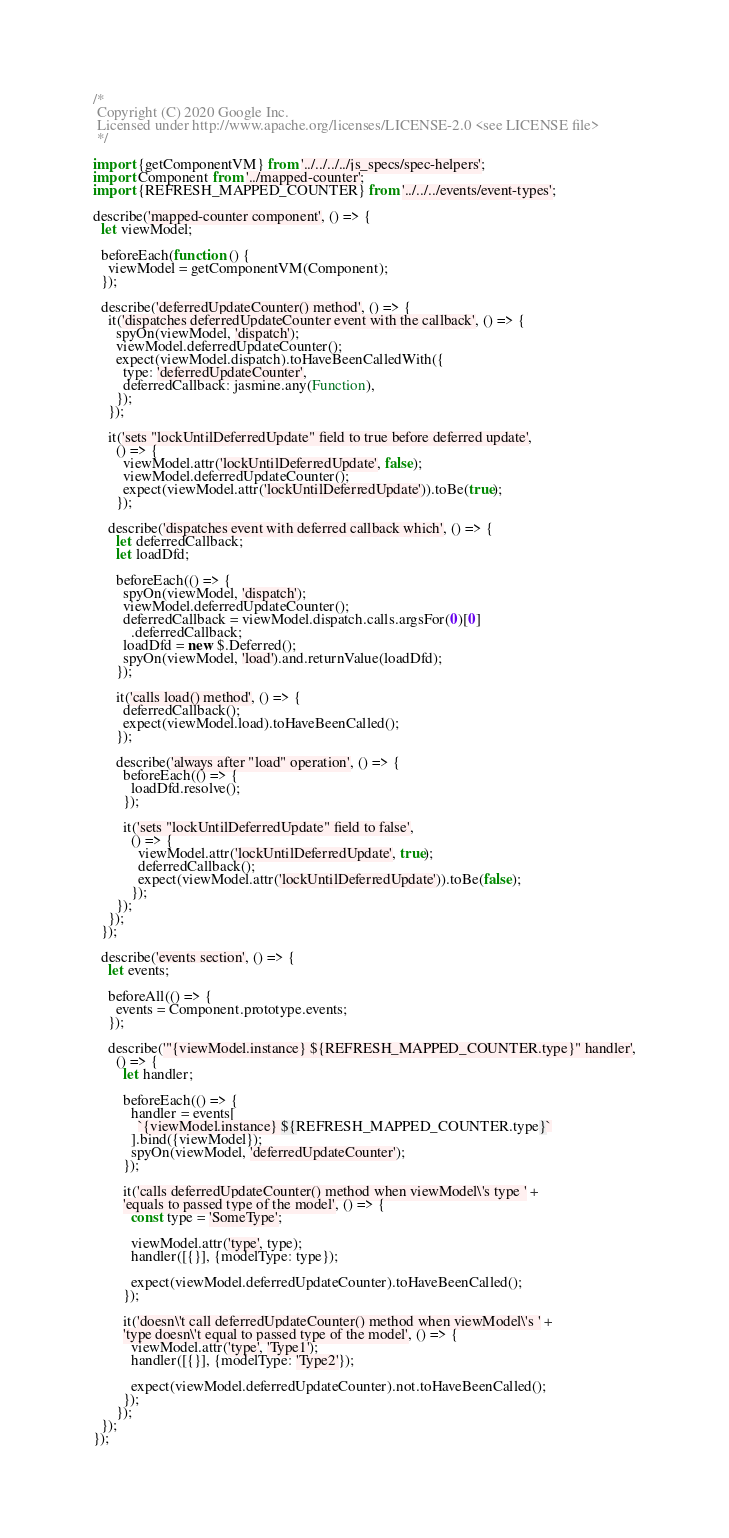Convert code to text. <code><loc_0><loc_0><loc_500><loc_500><_JavaScript_>/*
 Copyright (C) 2020 Google Inc.
 Licensed under http://www.apache.org/licenses/LICENSE-2.0 <see LICENSE file>
 */

import {getComponentVM} from '../../../../js_specs/spec-helpers';
import Component from '../mapped-counter';
import {REFRESH_MAPPED_COUNTER} from '../../../events/event-types';

describe('mapped-counter component', () => {
  let viewModel;

  beforeEach(function () {
    viewModel = getComponentVM(Component);
  });

  describe('deferredUpdateCounter() method', () => {
    it('dispatches deferredUpdateCounter event with the callback', () => {
      spyOn(viewModel, 'dispatch');
      viewModel.deferredUpdateCounter();
      expect(viewModel.dispatch).toHaveBeenCalledWith({
        type: 'deferredUpdateCounter',
        deferredCallback: jasmine.any(Function),
      });
    });

    it('sets "lockUntilDeferredUpdate" field to true before deferred update',
      () => {
        viewModel.attr('lockUntilDeferredUpdate', false);
        viewModel.deferredUpdateCounter();
        expect(viewModel.attr('lockUntilDeferredUpdate')).toBe(true);
      });

    describe('dispatches event with deferred callback which', () => {
      let deferredCallback;
      let loadDfd;

      beforeEach(() => {
        spyOn(viewModel, 'dispatch');
        viewModel.deferredUpdateCounter();
        deferredCallback = viewModel.dispatch.calls.argsFor(0)[0]
          .deferredCallback;
        loadDfd = new $.Deferred();
        spyOn(viewModel, 'load').and.returnValue(loadDfd);
      });

      it('calls load() method', () => {
        deferredCallback();
        expect(viewModel.load).toHaveBeenCalled();
      });

      describe('always after "load" operation', () => {
        beforeEach(() => {
          loadDfd.resolve();
        });

        it('sets "lockUntilDeferredUpdate" field to false',
          () => {
            viewModel.attr('lockUntilDeferredUpdate', true);
            deferredCallback();
            expect(viewModel.attr('lockUntilDeferredUpdate')).toBe(false);
          });
      });
    });
  });

  describe('events section', () => {
    let events;

    beforeAll(() => {
      events = Component.prototype.events;
    });

    describe('"{viewModel.instance} ${REFRESH_MAPPED_COUNTER.type}" handler',
      () => {
        let handler;

        beforeEach(() => {
          handler = events[
            `{viewModel.instance} ${REFRESH_MAPPED_COUNTER.type}`
          ].bind({viewModel});
          spyOn(viewModel, 'deferredUpdateCounter');
        });

        it('calls deferredUpdateCounter() method when viewModel\'s type ' +
        'equals to passed type of the model', () => {
          const type = 'SomeType';

          viewModel.attr('type', type);
          handler([{}], {modelType: type});

          expect(viewModel.deferredUpdateCounter).toHaveBeenCalled();
        });

        it('doesn\'t call deferredUpdateCounter() method when viewModel\'s ' +
        'type doesn\'t equal to passed type of the model', () => {
          viewModel.attr('type', 'Type1');
          handler([{}], {modelType: 'Type2'});

          expect(viewModel.deferredUpdateCounter).not.toHaveBeenCalled();
        });
      });
  });
});
</code> 